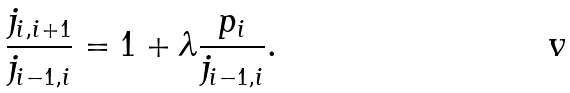Convert formula to latex. <formula><loc_0><loc_0><loc_500><loc_500>\frac { j _ { i , i + 1 } } { j _ { i - 1 , i } } = 1 + \lambda \frac { p _ { i } } { j _ { i - 1 , i } } .</formula> 